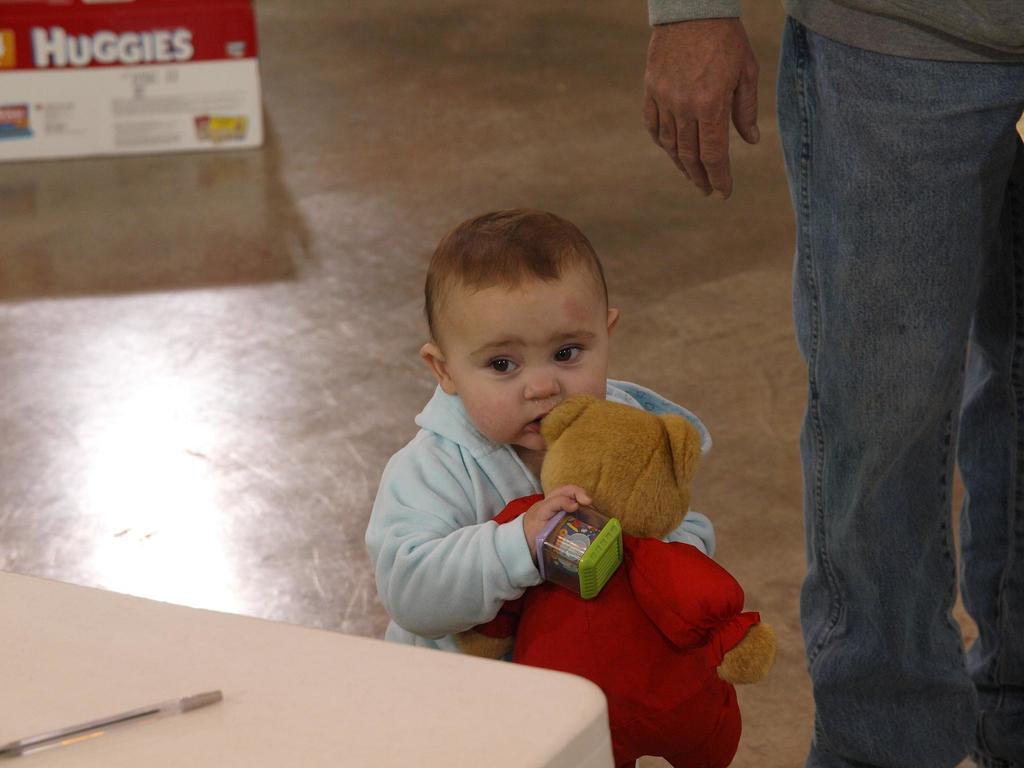Please provide a concise description of this image. In this picture here we can see small baby at the center who is holding teddy bear, teddy bear is having red color dress and the baby also holds some playing article. In the right we can see a person who is wearing blue jean and grey t-shirt. Also we have stool present on which a pen is there. Also we can see some box in the background. It looks like shop. 